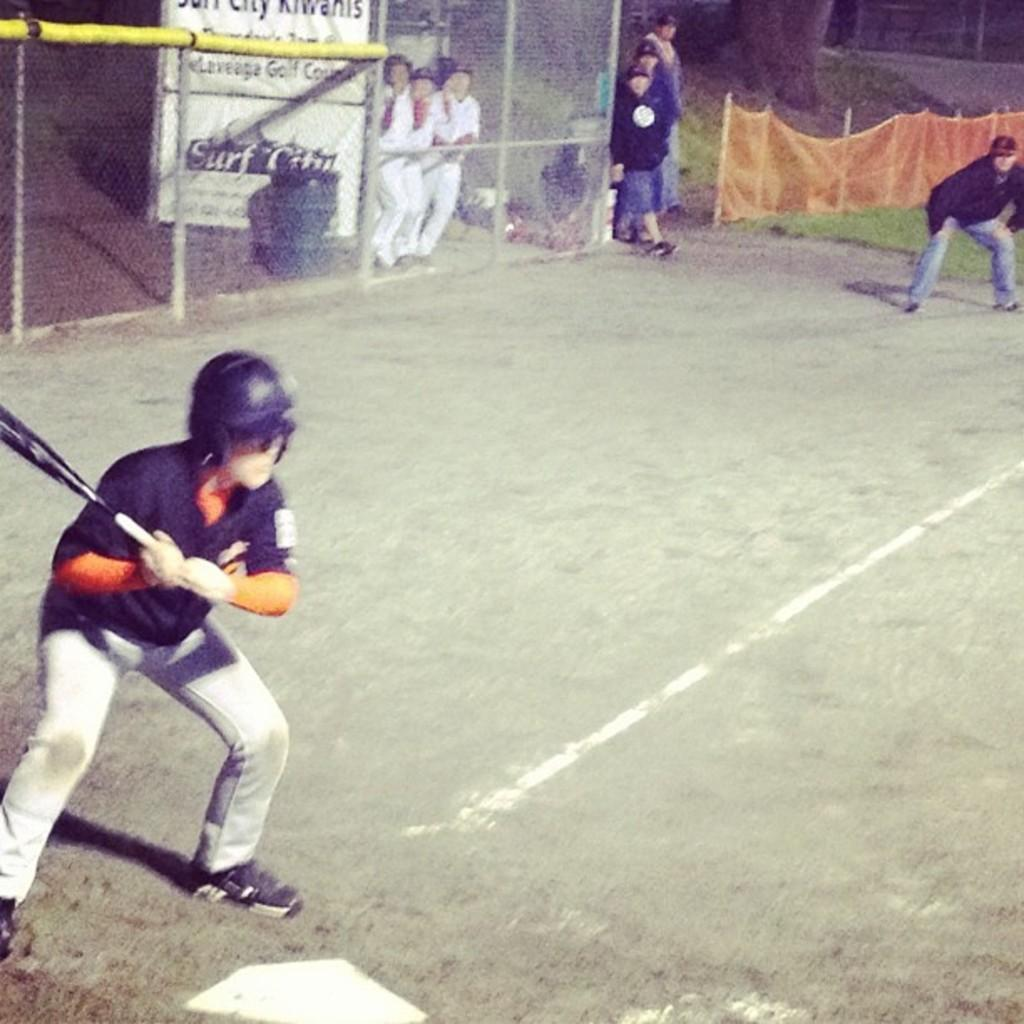<image>
Relay a brief, clear account of the picture shown. A baseball game takes place at a place called Surf City. 